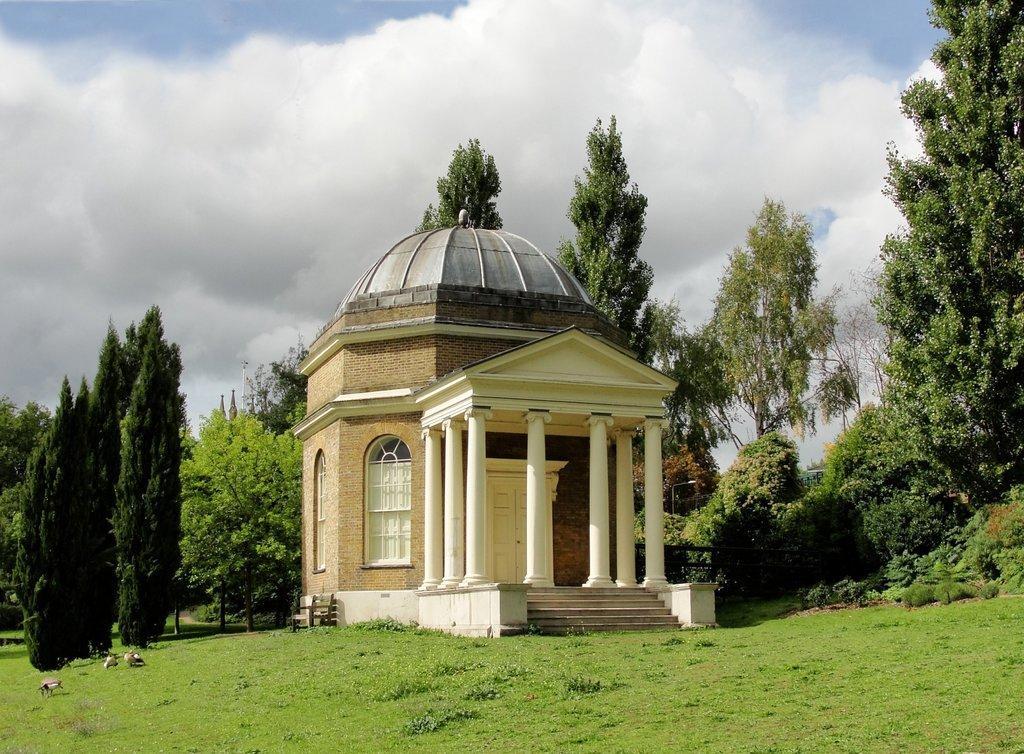Please provide a concise description of this image. In this image in the front there's grass on the ground. In the center there is a home and in the background there are trees and the sky is cloudy. There are birds on the ground in the center. 